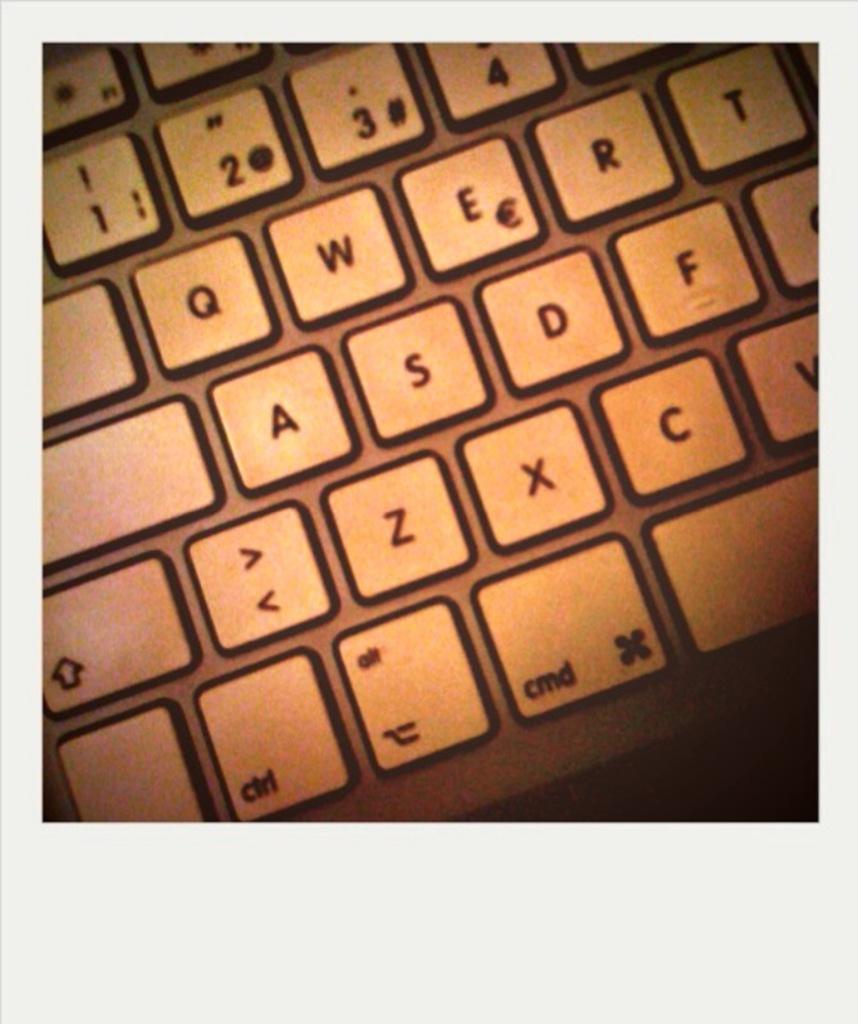Does the cmd key stand for command key?
Provide a succinct answer. Answering does not require reading text in the image. 